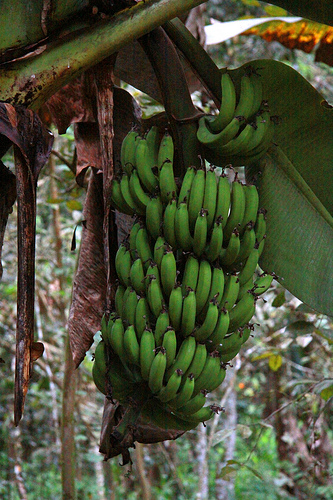Please provide the bounding box coordinate of the region this sentence describes: Dead brown leaf going down the left side of the bananas. The coordinates of the dead brown leaf on the left side of the bananas is [0.3, 0.17, 0.4, 0.74]. 